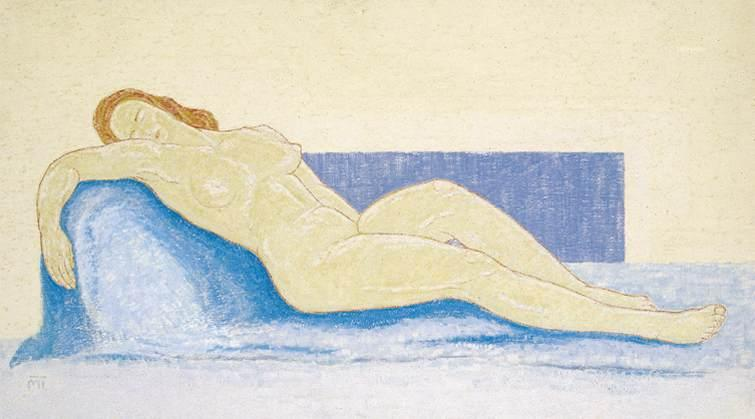Describe a possible backstory for this scene. Where is the woman, and why is she there? This scene might depict the woman in a serene, private studio or boudoir, a personal sanctuary where she comes to rest and rejuvenate. She could be an artist's muse, taking a break during a long session of posing. Alternatively, she might be enjoying a rare moment of solitude, having just completed a busy day of work or social engagements. The calm environment and her relaxed posture suggest she seeks refuge from the hustle and bustle of daily life, embracing a few precious moments of stillness and self-reflection. What might the artist's intentions be in creating this piece? The artist's intentions in creating this piece might be to capture and convey the beauty of tranquility and stillness. By depicting a nude figure in such a relaxed and serene state, the artist could be exploring themes of vulnerability, intimacy, and the intersection between the human form and the surrounding environment. The use of soft pastels and gentle curves might aim to evoke a sense of peace and comfort in the viewer, inviting them to pause and appreciate a moment of quiet beauty. Additionally, the artwork could be an exploration of the relationship between the subject and the space she occupies, highlighting the harmony and tension of this dynamic. 